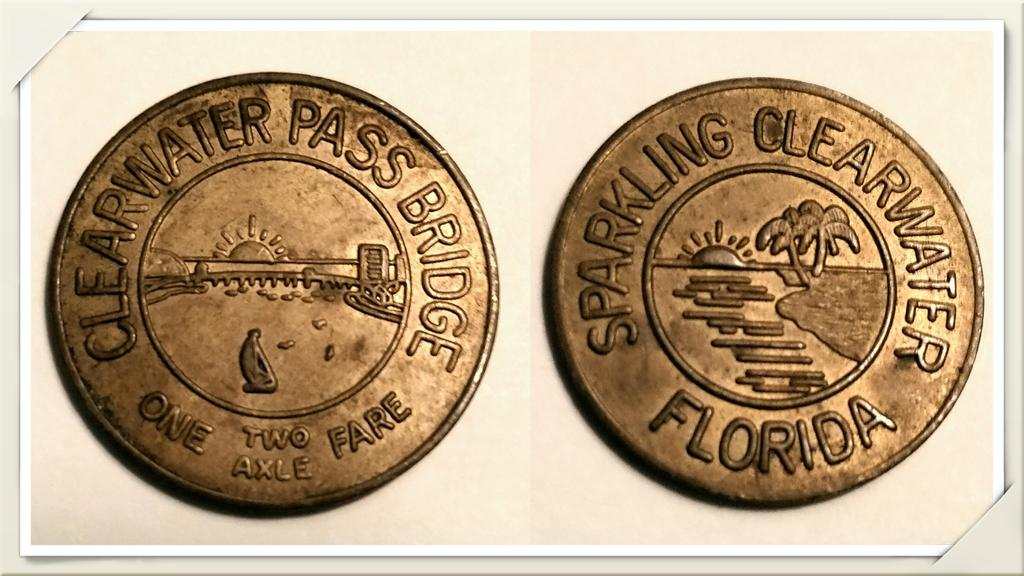<image>
Present a compact description of the photo's key features. Two copper coins next to one another with one saying Clearwater Pass Bridge. 